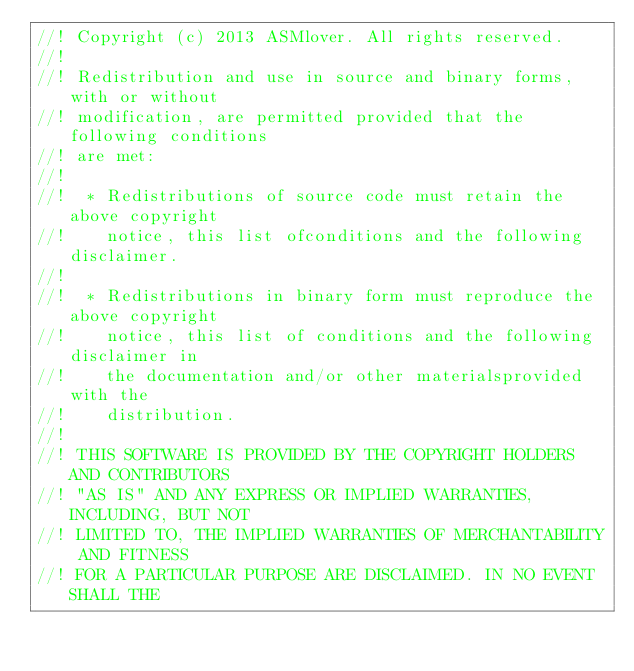<code> <loc_0><loc_0><loc_500><loc_500><_C++_>//! Copyright (c) 2013 ASMlover. All rights reserved.
//!
//! Redistribution and use in source and binary forms, with or without
//! modification, are permitted provided that the following conditions
//! are met:
//!
//!  * Redistributions of source code must retain the above copyright
//!    notice, this list ofconditions and the following disclaimer.
//!
//!  * Redistributions in binary form must reproduce the above copyright
//!    notice, this list of conditions and the following disclaimer in
//!    the documentation and/or other materialsprovided with the
//!    distribution.
//!
//! THIS SOFTWARE IS PROVIDED BY THE COPYRIGHT HOLDERS AND CONTRIBUTORS
//! "AS IS" AND ANY EXPRESS OR IMPLIED WARRANTIES, INCLUDING, BUT NOT
//! LIMITED TO, THE IMPLIED WARRANTIES OF MERCHANTABILITY AND FITNESS
//! FOR A PARTICULAR PURPOSE ARE DISCLAIMED. IN NO EVENT SHALL THE</code> 